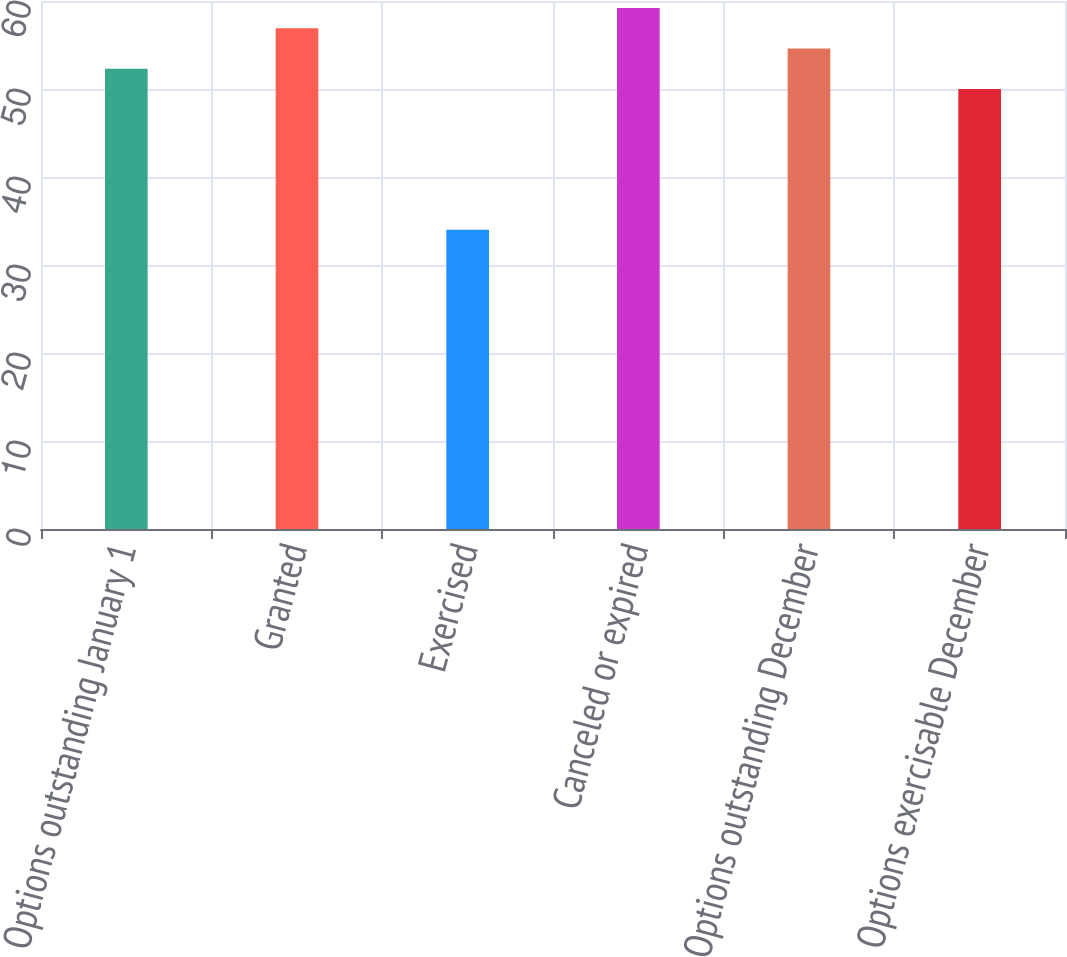<chart> <loc_0><loc_0><loc_500><loc_500><bar_chart><fcel>Options outstanding January 1<fcel>Granted<fcel>Exercised<fcel>Canceled or expired<fcel>Options outstanding December<fcel>Options exercisable December<nl><fcel>52.3<fcel>56.9<fcel>34<fcel>59.2<fcel>54.6<fcel>50<nl></chart> 